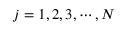Convert formula to latex. <formula><loc_0><loc_0><loc_500><loc_500>j = 1 , 2 , 3 , \cdots , N</formula> 